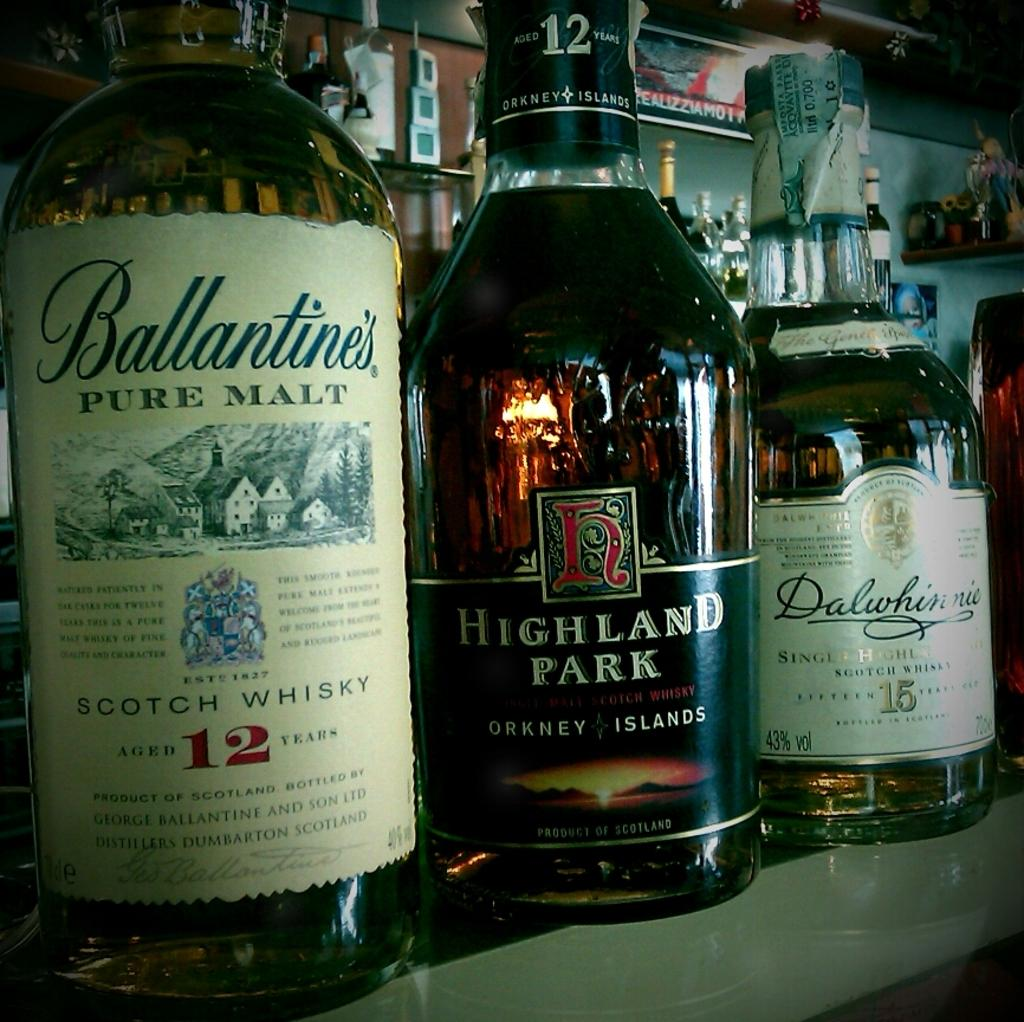<image>
Describe the image concisely. A row of whisky bottles by Highland Park and Ballantines sitting on a bar shelf. 